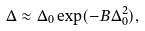<formula> <loc_0><loc_0><loc_500><loc_500>\Delta \approx \Delta _ { 0 } \exp ( - B \Delta _ { 0 } ^ { 2 } ) ,</formula> 